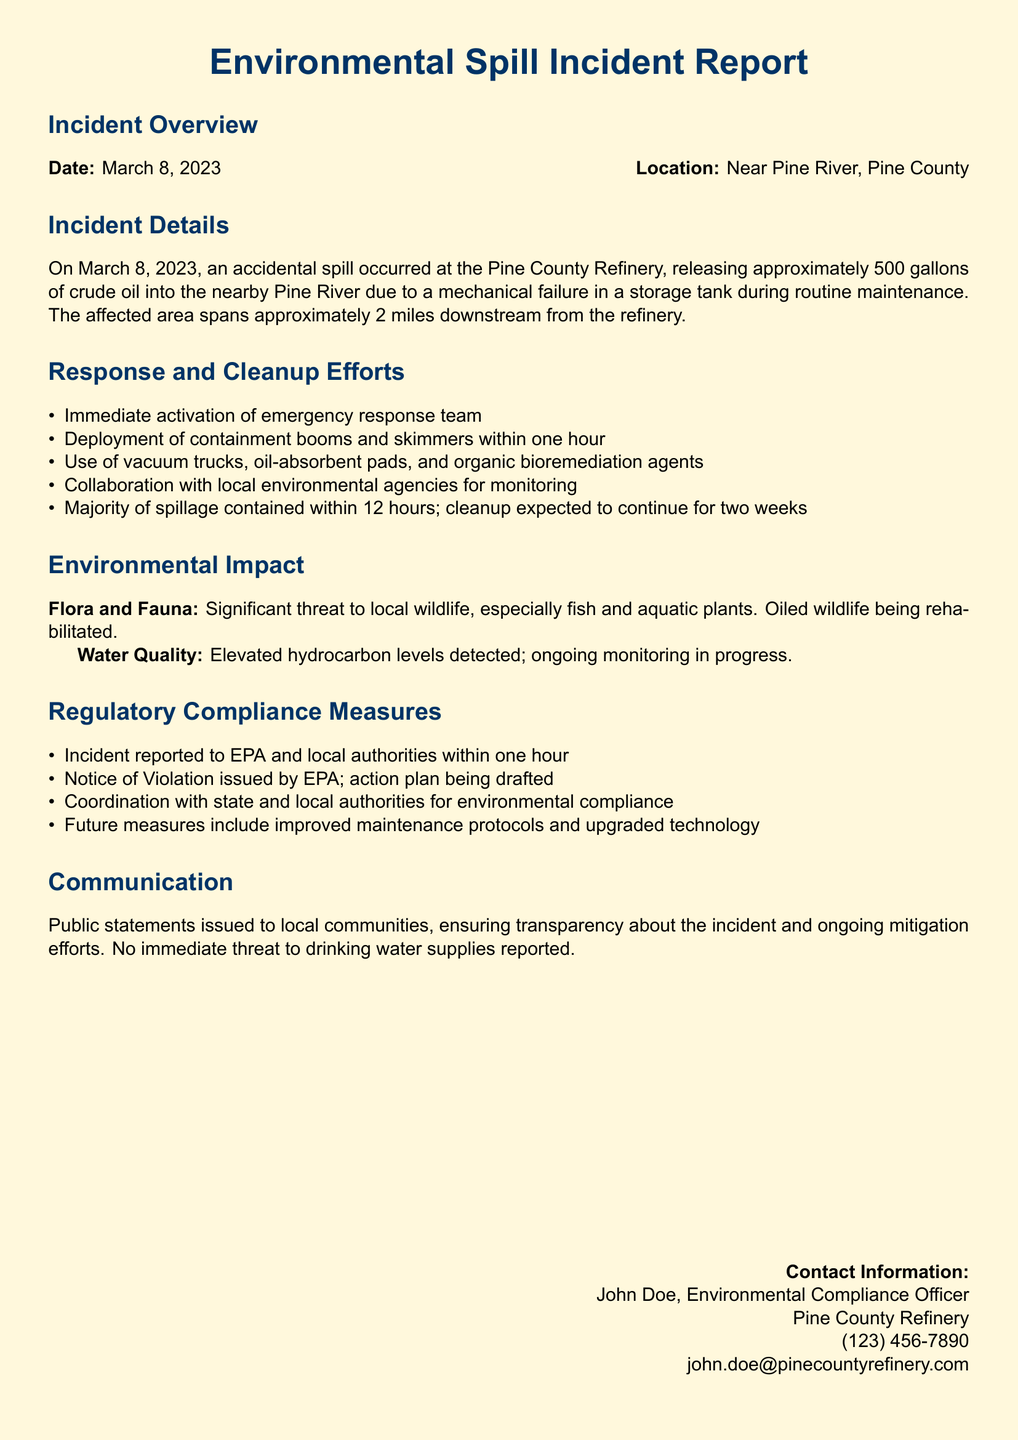what was the date of the incident? The incident occurred on March 8, 2023, as specified in the document.
Answer: March 8, 2023 how many gallons of crude oil were released? The document states that approximately 500 gallons of crude oil were released during the incident.
Answer: 500 gallons what immediate action was taken after the spill? The document indicates that the emergency response team was immediately activated upon the incident.
Answer: activation of emergency response team how long is the affected area downstream? The spill affected an area that spans approximately 2 miles downstream from the refinery.
Answer: 2 miles what is a significant threat mentioned in the environmental impact section? The environmental impact section states that there is a significant threat to local wildlife, especially fish and aquatic plants.
Answer: local wildlife how quickly were containment booms and skimmers deployed? The document mentions that containment booms and skimmers were deployed within one hour of the incident.
Answer: within one hour what compliance measure was taken regarding the EPA? The incident was reported to the EPA within one hour as noted in the regulatory compliance measures section.
Answer: reported to EPA what future measure is mentioned in the document? Future measures include improved maintenance protocols and upgraded technology according to the regulatory compliance section.
Answer: improved maintenance protocols and upgraded technology 